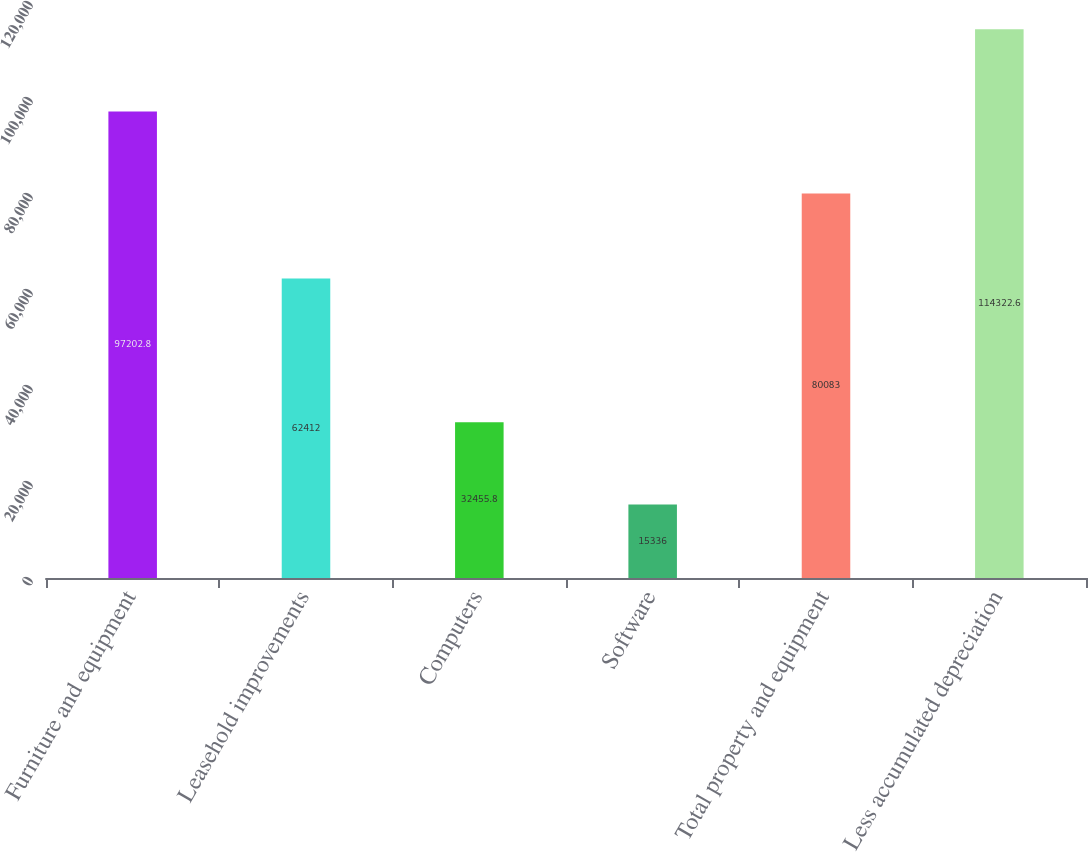Convert chart to OTSL. <chart><loc_0><loc_0><loc_500><loc_500><bar_chart><fcel>Furniture and equipment<fcel>Leasehold improvements<fcel>Computers<fcel>Software<fcel>Total property and equipment<fcel>Less accumulated depreciation<nl><fcel>97202.8<fcel>62412<fcel>32455.8<fcel>15336<fcel>80083<fcel>114323<nl></chart> 